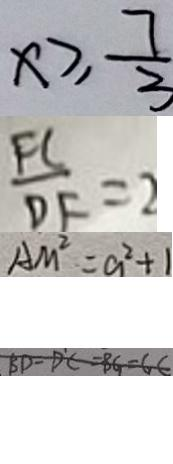Convert formula to latex. <formula><loc_0><loc_0><loc_500><loc_500>x \geq \frac { 7 } { 3 } 
 \frac { F C } { D F } = 2 
 A M ^ { 2 } = a ^ { 2 } + 1 
 B D = D C = B G = G C</formula> 